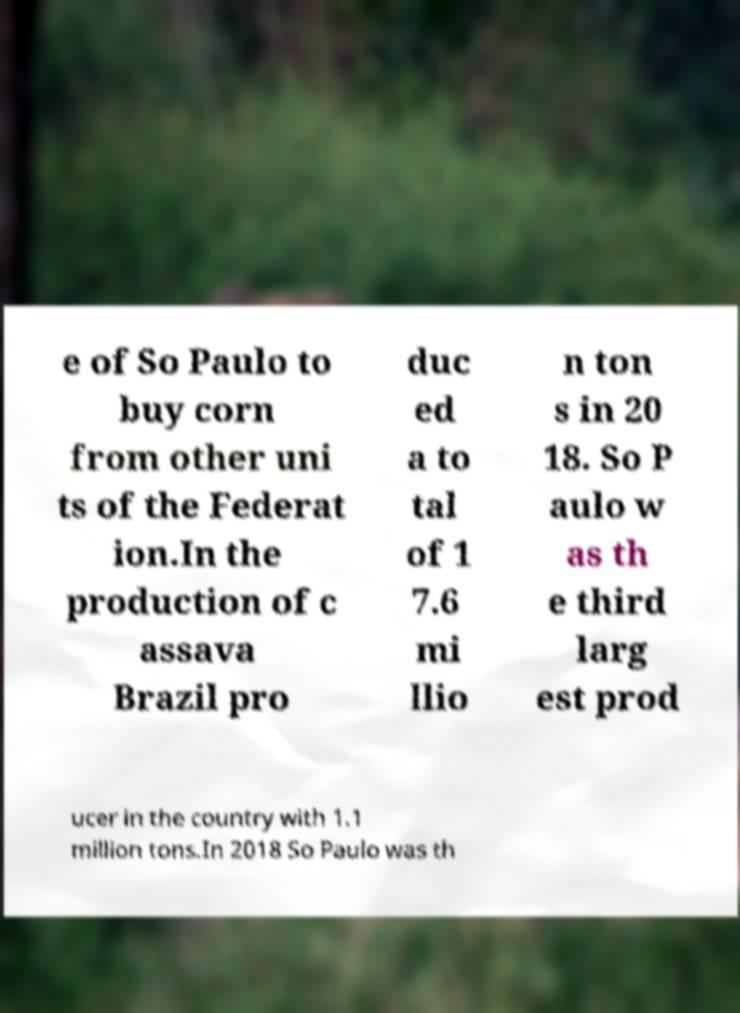For documentation purposes, I need the text within this image transcribed. Could you provide that? e of So Paulo to buy corn from other uni ts of the Federat ion.In the production of c assava Brazil pro duc ed a to tal of 1 7.6 mi llio n ton s in 20 18. So P aulo w as th e third larg est prod ucer in the country with 1.1 million tons.In 2018 So Paulo was th 